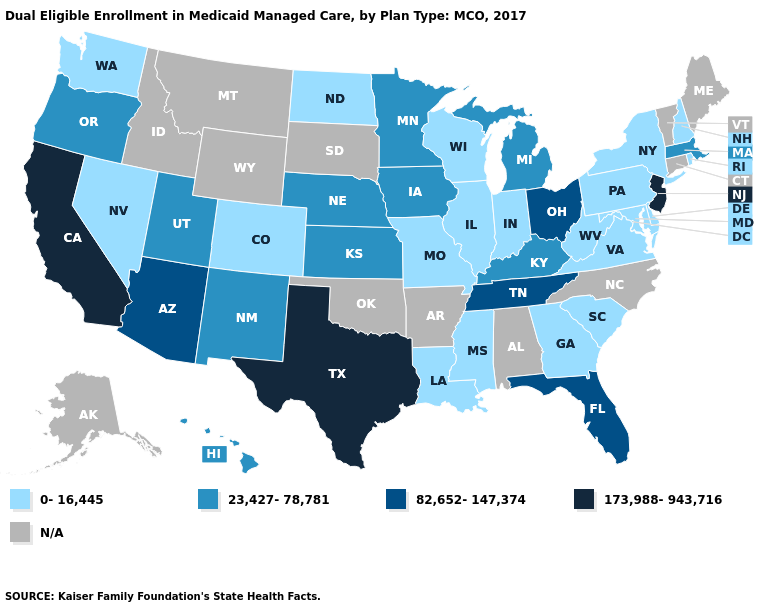What is the value of Kansas?
Give a very brief answer. 23,427-78,781. Which states have the highest value in the USA?
Concise answer only. California, New Jersey, Texas. What is the highest value in the Northeast ?
Concise answer only. 173,988-943,716. Does Utah have the lowest value in the USA?
Concise answer only. No. Which states hav the highest value in the MidWest?
Concise answer only. Ohio. Which states have the lowest value in the USA?
Concise answer only. Colorado, Delaware, Georgia, Illinois, Indiana, Louisiana, Maryland, Mississippi, Missouri, Nevada, New Hampshire, New York, North Dakota, Pennsylvania, Rhode Island, South Carolina, Virginia, Washington, West Virginia, Wisconsin. What is the value of Maryland?
Write a very short answer. 0-16,445. What is the highest value in states that border Wyoming?
Quick response, please. 23,427-78,781. Among the states that border Tennessee , which have the lowest value?
Answer briefly. Georgia, Mississippi, Missouri, Virginia. Name the states that have a value in the range 0-16,445?
Short answer required. Colorado, Delaware, Georgia, Illinois, Indiana, Louisiana, Maryland, Mississippi, Missouri, Nevada, New Hampshire, New York, North Dakota, Pennsylvania, Rhode Island, South Carolina, Virginia, Washington, West Virginia, Wisconsin. Does the map have missing data?
Concise answer only. Yes. Among the states that border Missouri , does Kansas have the lowest value?
Keep it brief. No. 